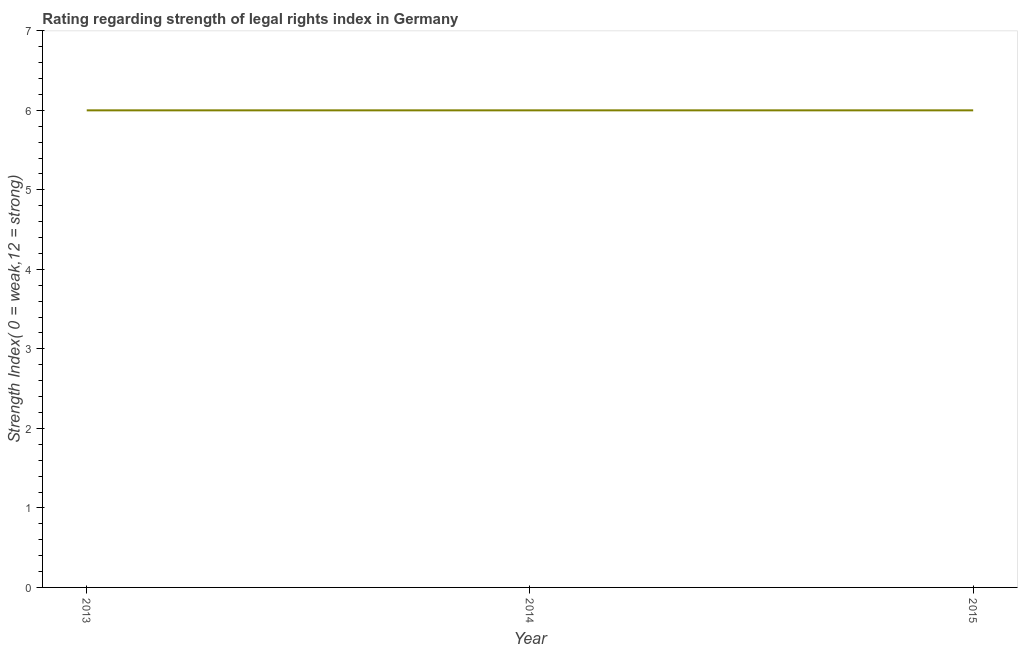What is the strength of legal rights index in 2013?
Your answer should be compact. 6. In which year was the strength of legal rights index minimum?
Offer a very short reply. 2013. What is the sum of the strength of legal rights index?
Offer a very short reply. 18. Do a majority of the years between 2013 and 2014 (inclusive) have strength of legal rights index greater than 2 ?
Offer a very short reply. Yes. Is the strength of legal rights index in 2014 less than that in 2015?
Your answer should be very brief. No. What is the difference between the highest and the second highest strength of legal rights index?
Offer a very short reply. 0. In how many years, is the strength of legal rights index greater than the average strength of legal rights index taken over all years?
Your response must be concise. 0. How many lines are there?
Your answer should be compact. 1. How many years are there in the graph?
Your answer should be very brief. 3. What is the difference between two consecutive major ticks on the Y-axis?
Offer a terse response. 1. Are the values on the major ticks of Y-axis written in scientific E-notation?
Provide a short and direct response. No. Does the graph contain grids?
Offer a terse response. No. What is the title of the graph?
Ensure brevity in your answer.  Rating regarding strength of legal rights index in Germany. What is the label or title of the X-axis?
Offer a terse response. Year. What is the label or title of the Y-axis?
Give a very brief answer. Strength Index( 0 = weak,12 = strong). What is the Strength Index( 0 = weak,12 = strong) of 2014?
Keep it short and to the point. 6. What is the Strength Index( 0 = weak,12 = strong) in 2015?
Give a very brief answer. 6. What is the difference between the Strength Index( 0 = weak,12 = strong) in 2013 and 2014?
Offer a very short reply. 0. What is the ratio of the Strength Index( 0 = weak,12 = strong) in 2013 to that in 2014?
Provide a succinct answer. 1. What is the ratio of the Strength Index( 0 = weak,12 = strong) in 2014 to that in 2015?
Offer a very short reply. 1. 